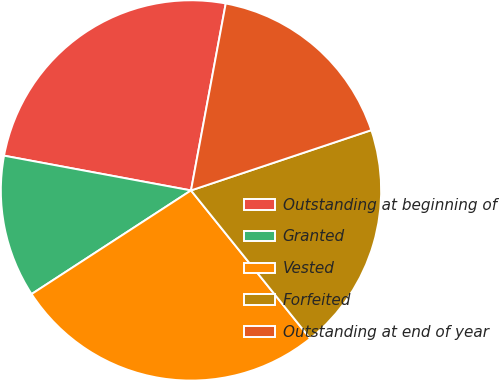Convert chart. <chart><loc_0><loc_0><loc_500><loc_500><pie_chart><fcel>Outstanding at beginning of<fcel>Granted<fcel>Vested<fcel>Forfeited<fcel>Outstanding at end of year<nl><fcel>25.0%<fcel>12.1%<fcel>26.61%<fcel>19.35%<fcel>16.94%<nl></chart> 